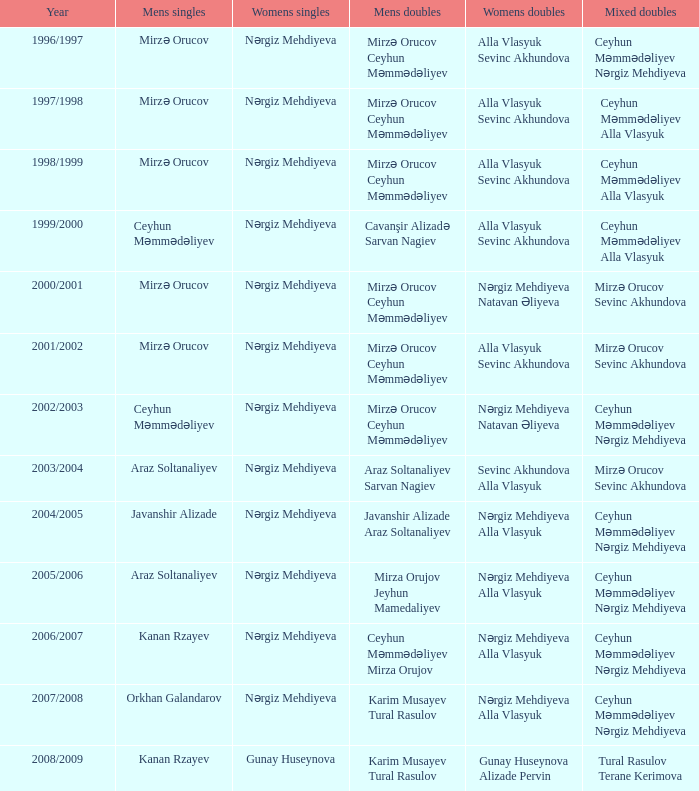What are all values for Womens Doubles in the year 2000/2001? Nərgiz Mehdiyeva Natavan Əliyeva. 